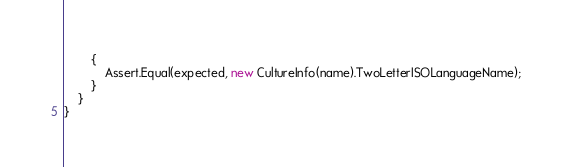Convert code to text. <code><loc_0><loc_0><loc_500><loc_500><_C#_>        {
            Assert.Equal(expected, new CultureInfo(name).TwoLetterISOLanguageName);
        }
    }
}
</code> 